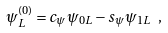<formula> <loc_0><loc_0><loc_500><loc_500>\psi _ { L } ^ { ( 0 ) } = c _ { \psi } \psi _ { 0 L } - s _ { \psi } \psi _ { 1 L } \ ,</formula> 